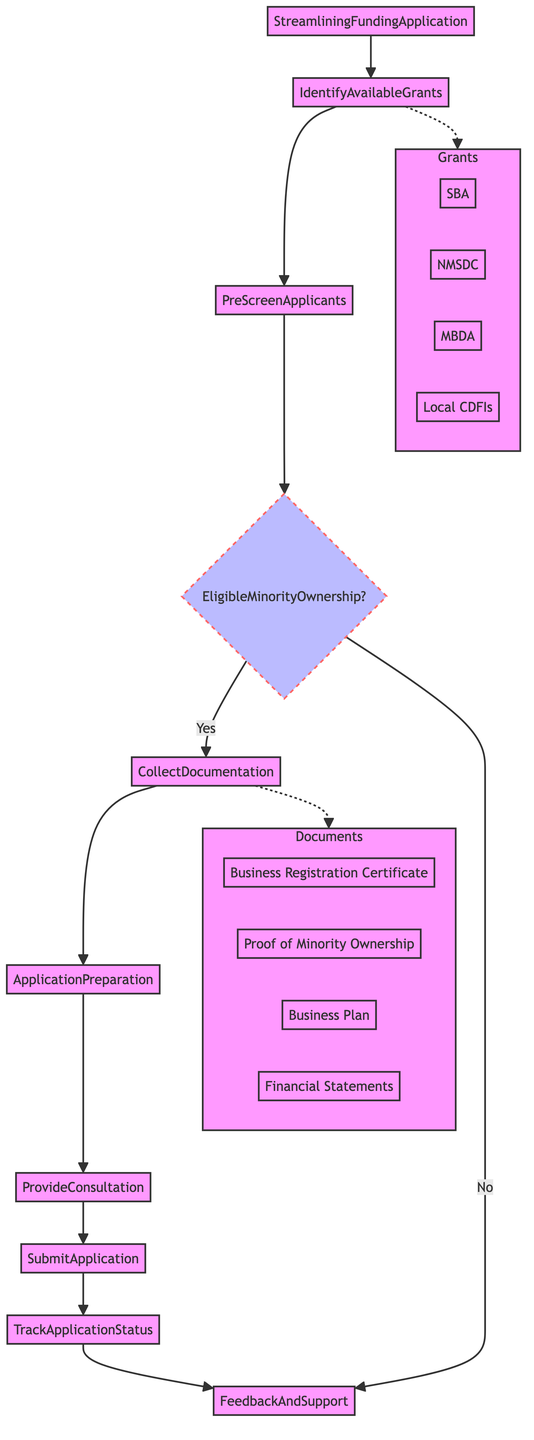What is the first step in the process? The first step in the process is represented by the node labeled "IdentifyAvailableGrants". It is the starting point of the flowchart.
Answer: IdentifyAvailableGrants How many total steps are there in the diagram? By counting the nodes connected in sequence, we see there are eight distinct operational steps in the flowchart.
Answer: Eight What happens if a business is not eligible due to minority ownership? In the flowchart, if a business does not meet the "EligibleMinorityOwnership" condition, it directly leads to the "FeedbackAndSupport" step, indicating there will be support even if the application is not approved.
Answer: FeedbackAndSupport Which documents are necessary to collect according to the flowchart? The diagram indicates a dotted line leading from the "CollectDocumentation" step to a subgraph labeled "Documents", which lists specific documents needed: "Business Registration Certificate", "Proof of Minority Ownership", "Business Plan", and "Financial Statements".
Answer: Business Registration Certificate, Proof of Minority Ownership, Business Plan, Financial Statements What is the last step in the funding application process? The final step in the flowchart is represented by the node labeled "FeedbackAndSupport", which occurs after tracking the application status.
Answer: FeedbackAndSupport How do applicants find out about available grants? According to the diagram, applicants are directed to "IdentifyAvailableGrants" to compile a list of funding opportunities, which is connected to the Grants subgraph that outlines specific grant sources.
Answer: IdentifyAvailableGrants What is the condition that must be satisfied concerning ownership? The flowchart specifies a conditional check labeled "EligibleMinorityOwnership", stating that businesses must be at least 51% owned by minority individuals to proceed.
Answer: At least 51% owned by minority individuals How many entities are included as grant sources in the diagram? The flowchart shows four distinct entities listed in the "Grants" subgraph, specifically "SBA", "NMSDC", "MBDA", and "Local CDFIs".
Answer: Four 